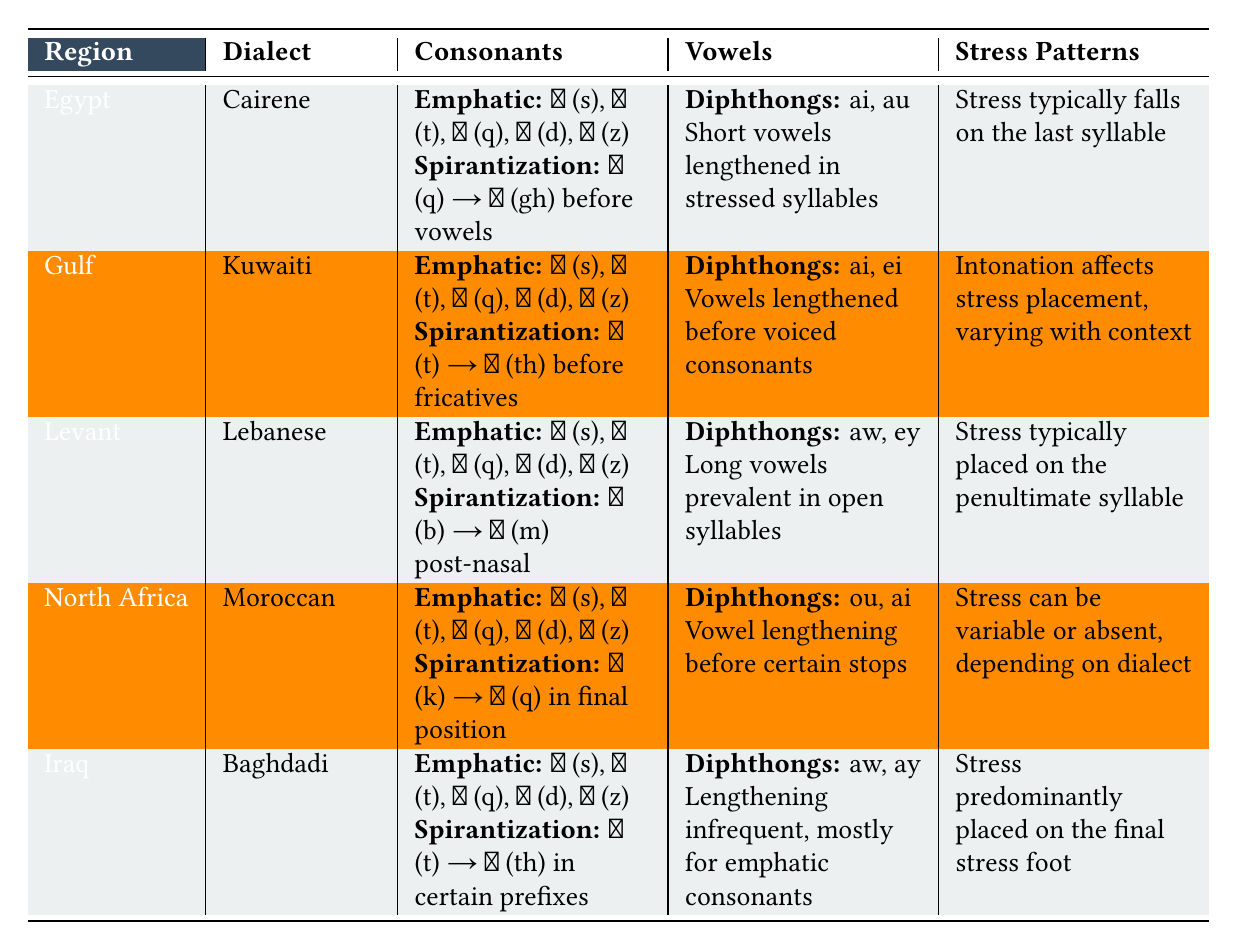What are the emphatic consonants in the Kuwaiti dialect? The table lists the emphatic consonants for the Kuwaiti dialect as ص (s), ط (t), ق (q), ض (d), and ظ (z).
Answer: ص (s), ط (t), ق (q), ض (d), ظ (z) Which dialect has lengthening of short vowels occurring in stressed syllables? The table shows that in the Cairene dialect, short vowels tend to be lengthened in stressed syllables.
Answer: Cairene What is the common feature of spirantization for the Lebanese dialect? The Lebanese dialect specifies that ب (b) spirantizes to م (m) after nasal sounds, according to the table.
Answer: ب (b) → م (m) post-nasal How many different diphthongs are mentioned for the Moroccan dialect? The table indicates that there are two diphthongs listed for the Moroccan dialect: ou and ai.
Answer: 2 Does the Kuwaiti dialect have a different pattern of stress placement compared to the Cairene dialect? The Kuwaiti dialect has stress placement affected by intonation and varies with context, while the Cairene dialect typically places stress on the last syllable. This suggests a difference in stress patterns.
Answer: Yes Which dialect exhibits variable stress or lack of stress? The table states that the Moroccan dialect can have variable or absent stress depending on the dialect.
Answer: Moroccan In which dialect do vowels lengthen primarily before voiced consonants? The table shows that in the Kuwaiti dialect, vowels are lengthened before voiced consonants.
Answer: Kuwaiti Compare the stress placement of the Baghdadi dialect with the Lebanese dialect. The Baghdadi dialect predominantly places stress on the final stress foot, while the Lebanese dialect places stress typically on the penultimate syllable, indicating a contrasting pattern.
Answer: Yes, they differ What is the primary condition for spirantization in the Gulf dialect? According to the table, the primary condition for spirantization in the Kuwaiti dialect occurs before fricatives, specifically ت (t) → ث (th).
Answer: Before fricatives How many distinct regions are represented in the table? The table lists five distinct regions: Egypt, Gulf, Levant, North Africa, and Iraq.
Answer: 5 